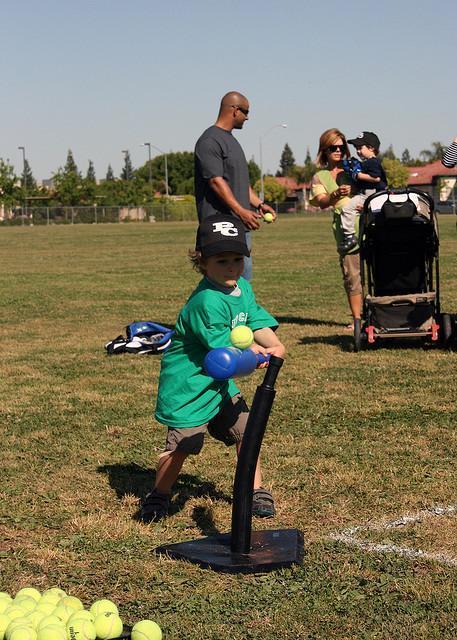How many children are visible?
Give a very brief answer. 2. How many sports balls are there?
Give a very brief answer. 1. How many people are there?
Give a very brief answer. 4. In how many of these screen shots is the skateboard touching the ground?
Give a very brief answer. 0. 